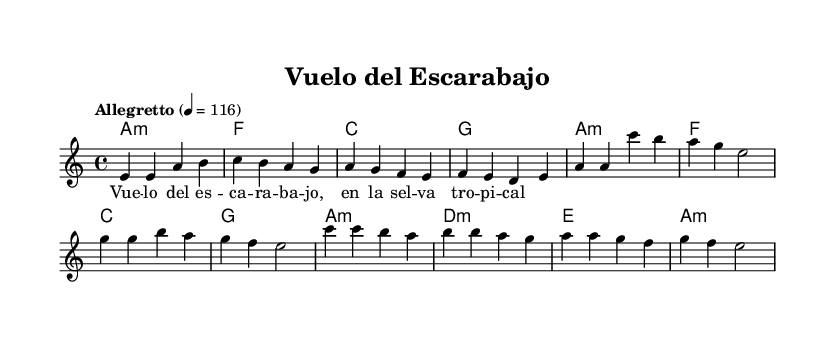What is the key signature of this music? The key signature is indicated at the beginning of the music sheet; in this case, it's A minor, which contains a natural sign. Since A minor is the relative minor of C major, it has no sharps or flats.
Answer: A minor What is the time signature of this music? The time signature is shown at the beginning of the music. Here, it is 4/4, meaning there are four beats in each measure and the quarter note gets one beat.
Answer: 4/4 What is the tempo marking of this music? The tempo marking is located at the beginning of the score, indicated with the word "Allegretto" and the metronome marking of quarter note equals 116. This indicates the speed of the performance.
Answer: Allegretto How many measures are in the chorus section of the piece? To determine the number of measures in the chorus, we can count the measures specified under the chorus section in the melody. The chorus consists of four measures.
Answer: 4 What is the first note of the melody? The first note of the melody is found at the start of the melody section, where the notes begin. It is E.
Answer: E Which chord follows the second measure of the verse? By examining the chord progression alongside the melody, we can identify the chords for the verse. The second measure of the verse has the chord G major following the A minor in the first measure.
Answer: G What lyrics correspond to the first measure of the melody? The lyrics are written underneath the melody notes. The first measure corresponds to "Vue" as it aligns directly beneath the first note E.
Answer: Vue 